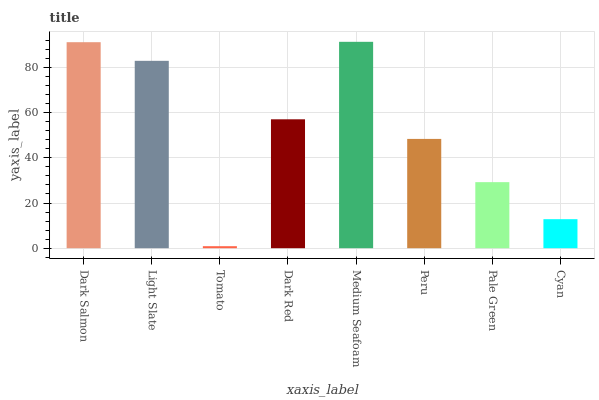Is Tomato the minimum?
Answer yes or no. Yes. Is Medium Seafoam the maximum?
Answer yes or no. Yes. Is Light Slate the minimum?
Answer yes or no. No. Is Light Slate the maximum?
Answer yes or no. No. Is Dark Salmon greater than Light Slate?
Answer yes or no. Yes. Is Light Slate less than Dark Salmon?
Answer yes or no. Yes. Is Light Slate greater than Dark Salmon?
Answer yes or no. No. Is Dark Salmon less than Light Slate?
Answer yes or no. No. Is Dark Red the high median?
Answer yes or no. Yes. Is Peru the low median?
Answer yes or no. Yes. Is Tomato the high median?
Answer yes or no. No. Is Cyan the low median?
Answer yes or no. No. 